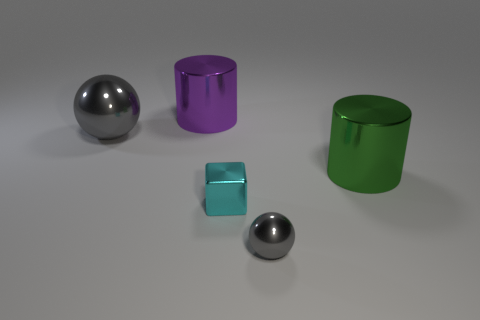Is the shape of the big purple object the same as the green thing?
Make the answer very short. Yes. What number of shiny objects are either big green things or brown cylinders?
Ensure brevity in your answer.  1. What material is the other sphere that is the same color as the tiny ball?
Keep it short and to the point. Metal. Is the size of the purple cylinder the same as the cyan cube?
Your answer should be very brief. No. What number of objects are large metal spheres or gray spheres behind the big green cylinder?
Provide a succinct answer. 1. What is the material of the green cylinder that is the same size as the purple thing?
Make the answer very short. Metal. What material is the large object that is both in front of the purple shiny thing and left of the tiny cyan cube?
Your answer should be very brief. Metal. There is a gray metal sphere that is left of the shiny cube; is there a purple shiny cylinder that is behind it?
Your answer should be compact. Yes. What size is the object that is on the left side of the block and in front of the big purple shiny thing?
Your response must be concise. Large. How many yellow objects are either small cubes or big metallic spheres?
Offer a terse response. 0. 